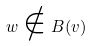<formula> <loc_0><loc_0><loc_500><loc_500>w \notin B ( v )</formula> 